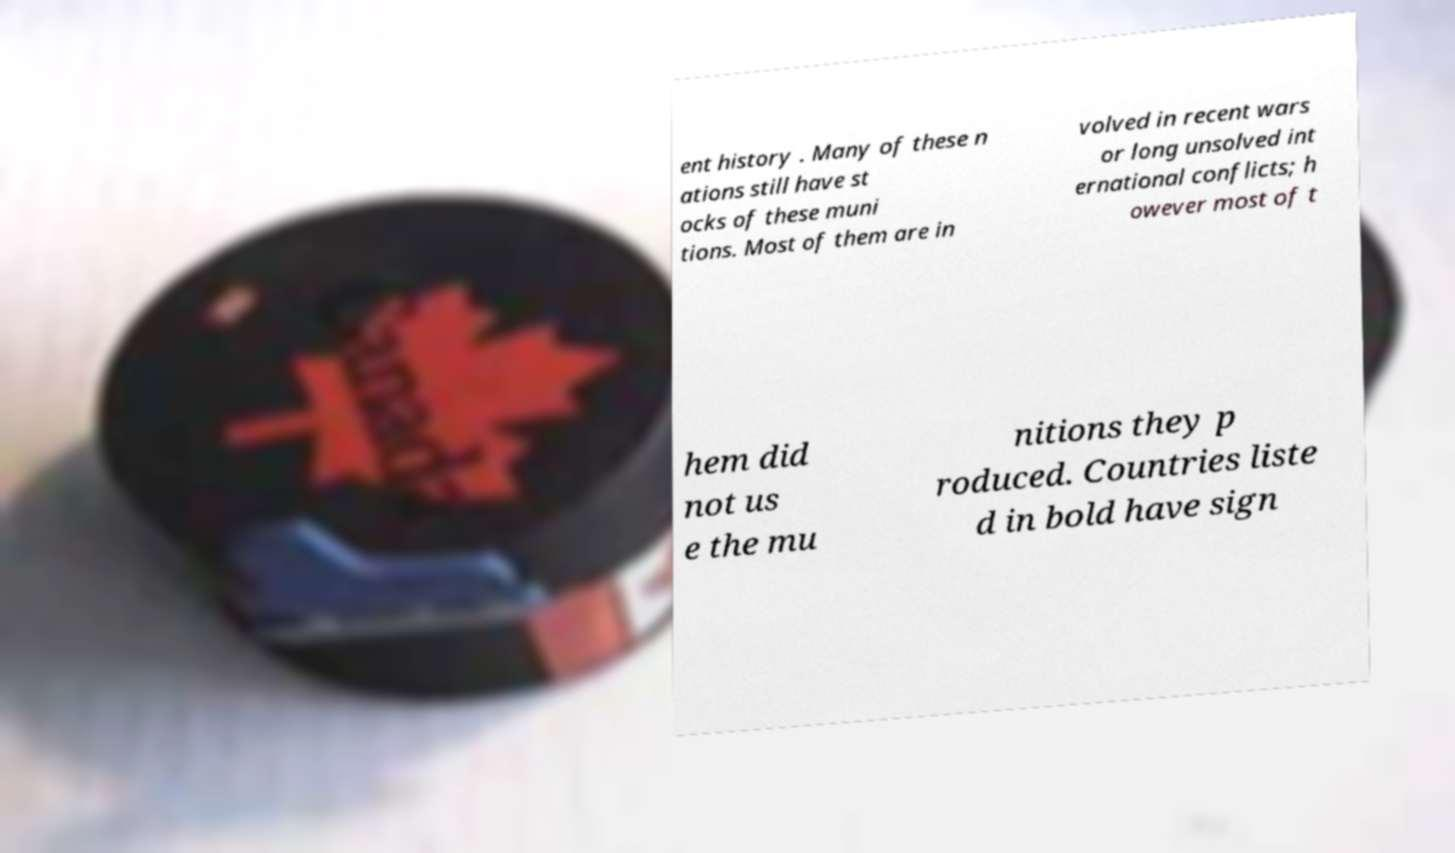Please identify and transcribe the text found in this image. ent history . Many of these n ations still have st ocks of these muni tions. Most of them are in volved in recent wars or long unsolved int ernational conflicts; h owever most of t hem did not us e the mu nitions they p roduced. Countries liste d in bold have sign 